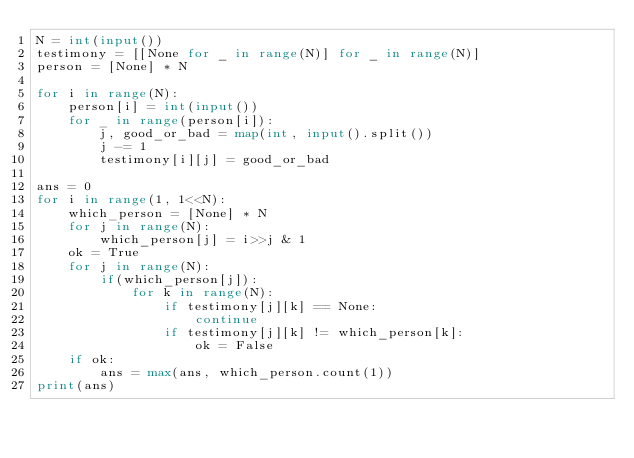Convert code to text. <code><loc_0><loc_0><loc_500><loc_500><_Python_>N = int(input())
testimony = [[None for _ in range(N)] for _ in range(N)]
person = [None] * N

for i in range(N):
    person[i] = int(input())
    for _ in range(person[i]):
        j, good_or_bad = map(int, input().split())
        j -= 1
        testimony[i][j] = good_or_bad

ans = 0
for i in range(1, 1<<N):
    which_person = [None] * N
    for j in range(N):
        which_person[j] = i>>j & 1
    ok = True
    for j in range(N):
        if(which_person[j]): 
            for k in range(N):
                if testimony[j][k] == None: 
                    continue
                if testimony[j][k] != which_person[k]:
                    ok = False
    if ok:
        ans = max(ans, which_person.count(1))
print(ans)</code> 